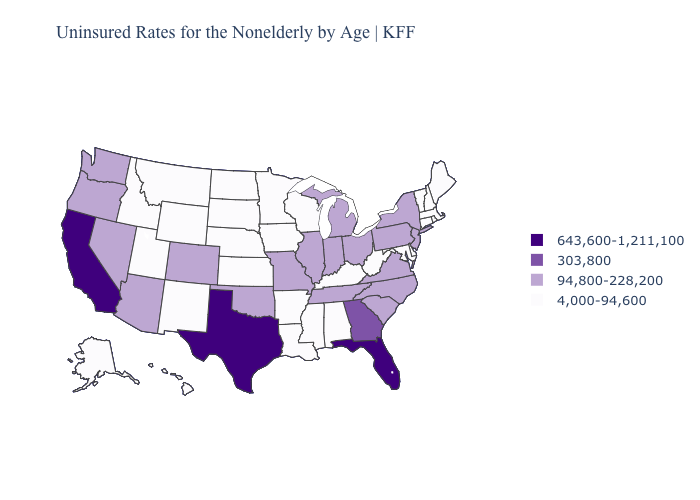What is the value of Florida?
Concise answer only. 643,600-1,211,100. Does the map have missing data?
Answer briefly. No. Name the states that have a value in the range 643,600-1,211,100?
Be succinct. California, Florida, Texas. Does West Virginia have the same value as Indiana?
Concise answer only. No. Does Connecticut have a lower value than Missouri?
Be succinct. Yes. Does New Hampshire have a lower value than New Mexico?
Concise answer only. No. What is the value of Iowa?
Write a very short answer. 4,000-94,600. Does Connecticut have the lowest value in the Northeast?
Concise answer only. Yes. What is the highest value in the USA?
Answer briefly. 643,600-1,211,100. Which states have the lowest value in the USA?
Write a very short answer. Alabama, Alaska, Arkansas, Connecticut, Delaware, Hawaii, Idaho, Iowa, Kansas, Kentucky, Louisiana, Maine, Maryland, Massachusetts, Minnesota, Mississippi, Montana, Nebraska, New Hampshire, New Mexico, North Dakota, Rhode Island, South Dakota, Utah, Vermont, West Virginia, Wisconsin, Wyoming. Name the states that have a value in the range 643,600-1,211,100?
Keep it brief. California, Florida, Texas. Does Washington have the lowest value in the USA?
Write a very short answer. No. What is the value of Rhode Island?
Keep it brief. 4,000-94,600. Name the states that have a value in the range 643,600-1,211,100?
Quick response, please. California, Florida, Texas. Does Maryland have a higher value than South Carolina?
Keep it brief. No. 